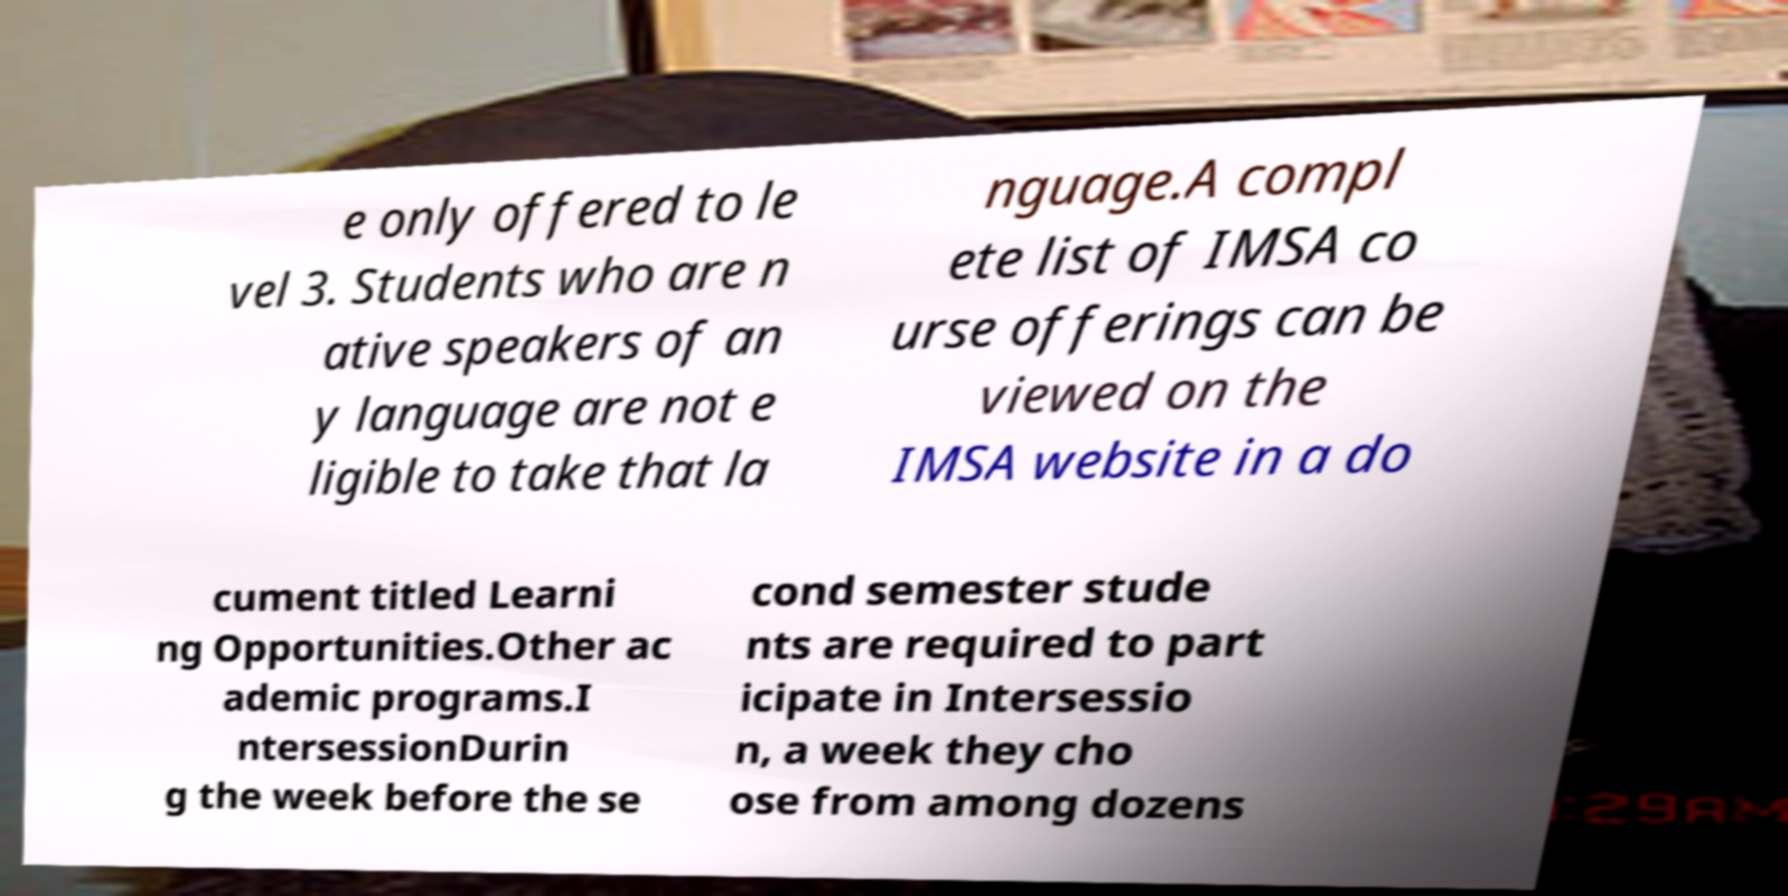Could you assist in decoding the text presented in this image and type it out clearly? e only offered to le vel 3. Students who are n ative speakers of an y language are not e ligible to take that la nguage.A compl ete list of IMSA co urse offerings can be viewed on the IMSA website in a do cument titled Learni ng Opportunities.Other ac ademic programs.I ntersessionDurin g the week before the se cond semester stude nts are required to part icipate in Intersessio n, a week they cho ose from among dozens 